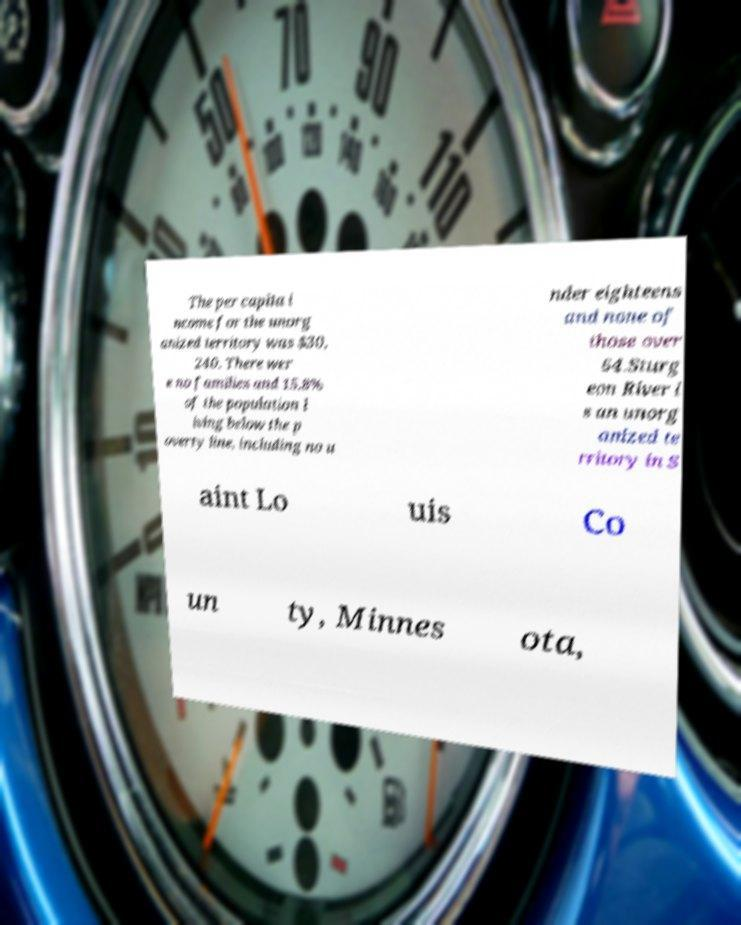Can you read and provide the text displayed in the image?This photo seems to have some interesting text. Can you extract and type it out for me? The per capita i ncome for the unorg anized territory was $30, 240. There wer e no families and 15.8% of the population l iving below the p overty line, including no u nder eighteens and none of those over 64.Sturg eon River i s an unorg anized te rritory in S aint Lo uis Co un ty, Minnes ota, 